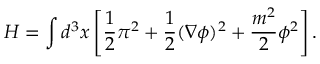Convert formula to latex. <formula><loc_0><loc_0><loc_500><loc_500>H = \int d ^ { 3 } x \left [ { \frac { 1 } { 2 } } \pi ^ { 2 } + { \frac { 1 } { 2 } } ( \nabla \phi ) ^ { 2 } + { \frac { m ^ { 2 } } { 2 } } \phi ^ { 2 } \right ] .</formula> 